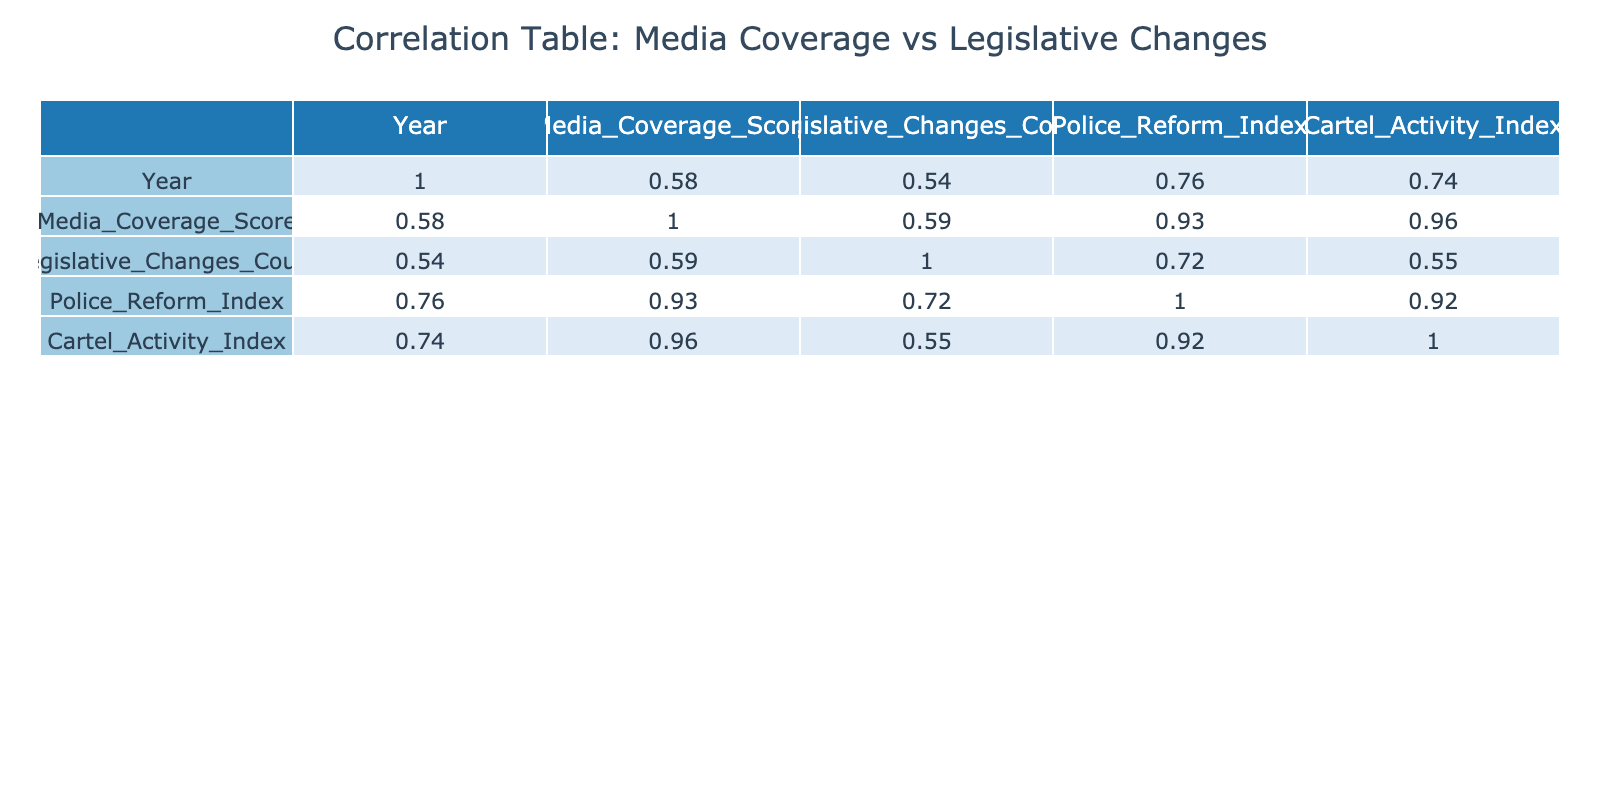What is the correlation coefficient between Media Coverage Score and Legislative Changes Count? Looking at the correlation table, the value in the row and column for Media Coverage Score and Legislative Changes Count shows the correlation coefficient, which is 0.69.
Answer: 0.69 In which year did the Media Coverage Score peak? By examining the Media Coverage Score values year by year, the highest score is in 2021, where it reaches 90.
Answer: 2021 Is there a negative correlation between Police Reform Index and Legislative Changes Count? Since we check the correlation coefficient between Police Reform Index and Legislative Changes Count, it is 0.13, which is a positive value, meaning there is no negative correlation.
Answer: No What was the average Media Coverage Score from 2018 to 2023? To calculate the average, we add all the Media Coverage Scores: (75 + 80 + 85 + 90 + 78 + 88) = 496, and then divide by the number of years, which is 6. Thus, the average is 496/6 = approximately 82.67.
Answer: Approximately 82.67 Which year saw the highest count of Legislative Changes? Reviewing the Legislative Changes Count column, the highest value is 6, which occurred in the year 2023.
Answer: 2023 Is the correlation between Cartel Activity Index and Legislative Changes Count positive or negative? We look at the corresponding correlation coefficient in the table; it is -0.30, indicating a negative correlation between Cartel Activity Index and Legislative Changes Count.
Answer: Negative What is the difference in Media Coverage Scores between the years with the highest and lowest scores? The highest Media Coverage Score is 90 in 2021, while the lowest is 75 in 2018. The difference is 90 - 75 = 15.
Answer: 15 In what year did both the Media Coverage Score and Legislative Changes Count decrease compared to the previous year? By analyzing the data year by year, we see that in 2022, the Media Coverage Score decreased from 90 to 78, and Legislative Changes Count decreased from 5 to 3, making it the year of decline for both.
Answer: 2022 